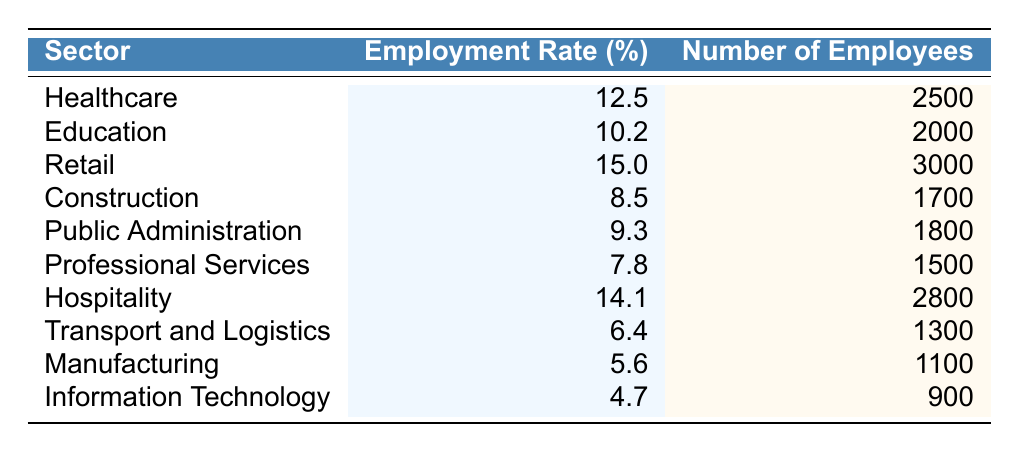What sector has the highest employment rate in Porirua for 2023? By looking at the table, I see the employment rates for each sector. The sector with the highest percentage is Retail at 15.0%.
Answer: Retail How many employees work in the Healthcare sector? The table shows that the number of employees in the Healthcare sector is 2500.
Answer: 2500 What is the average employment rate of all sectors listed? To calculate the average, I sum all employment rates: 12.5 + 10.2 + 15.0 + 8.5 + 9.3 + 7.8 + 14.1 + 6.4 + 5.6 + 4.7 = 94.1. There are 10 sectors, so the average is 94.1 / 10 = 9.41.
Answer: 9.41 Are there more employees in the Hospitality sector than in the Transport and Logistics sector? The number of employees in Hospitality is 2800, while in Transport and Logistics it is 1300. Since 2800 is greater than 1300, the answer is yes.
Answer: Yes What is the difference in employment rate between Retail and Manufacturing? The employment rate for Retail is 15.0% and for Manufacturing is 5.6%. The difference is 15.0% - 5.6% = 9.4%.
Answer: 9.4% Which sector has fewer employees: Information Technology or Professional Services? Information Technology has 900 employees and Professional Services has 1500 employees. Since 900 is less than 1500, Information Technology has fewer employees.
Answer: Information Technology If we combine the number of employees from Construction and Public Administration, how many employees would that be? The number of employees in Construction is 1700 and in Public Administration is 1800. Adding these together: 1700 + 1800 = 3500.
Answer: 3500 What percentage of employees in Porirua work in the Manufacturing sector? The number of employees in Manufacturing is 1100. To find the percentage, divide the number of employees in Manufacturing (1100) by the total number of employees across all sectors (which sums to 21,400) and multiply by 100. The percentage is (1100 / 21400) * 100 = 5.14%.
Answer: 5.14% Does the Public Administration sector have a higher employment rate than the Professional Services sector? Public Administration has an employment rate of 9.3%, while Professional Services has 7.8%. Since 9.3% is greater than 7.8%, the statement is true.
Answer: Yes What sectors have employment rates greater than 10%? By checking the employment rates, Healthcare (12.5%), Retail (15.0%), Hospitality (14.1%), and Education (10.2%) are the only sectors that have rates over 10%.
Answer: Healthcare, Retail, Hospitality, Education 